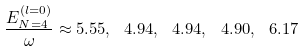Convert formula to latex. <formula><loc_0><loc_0><loc_500><loc_500>\frac { E _ { N = 4 } ^ { ( l = 0 ) } } { \omega } \approx 5 . 5 5 , \ 4 . 9 4 , \ 4 . 9 4 , \ 4 . 9 0 , \ 6 . 1 7</formula> 